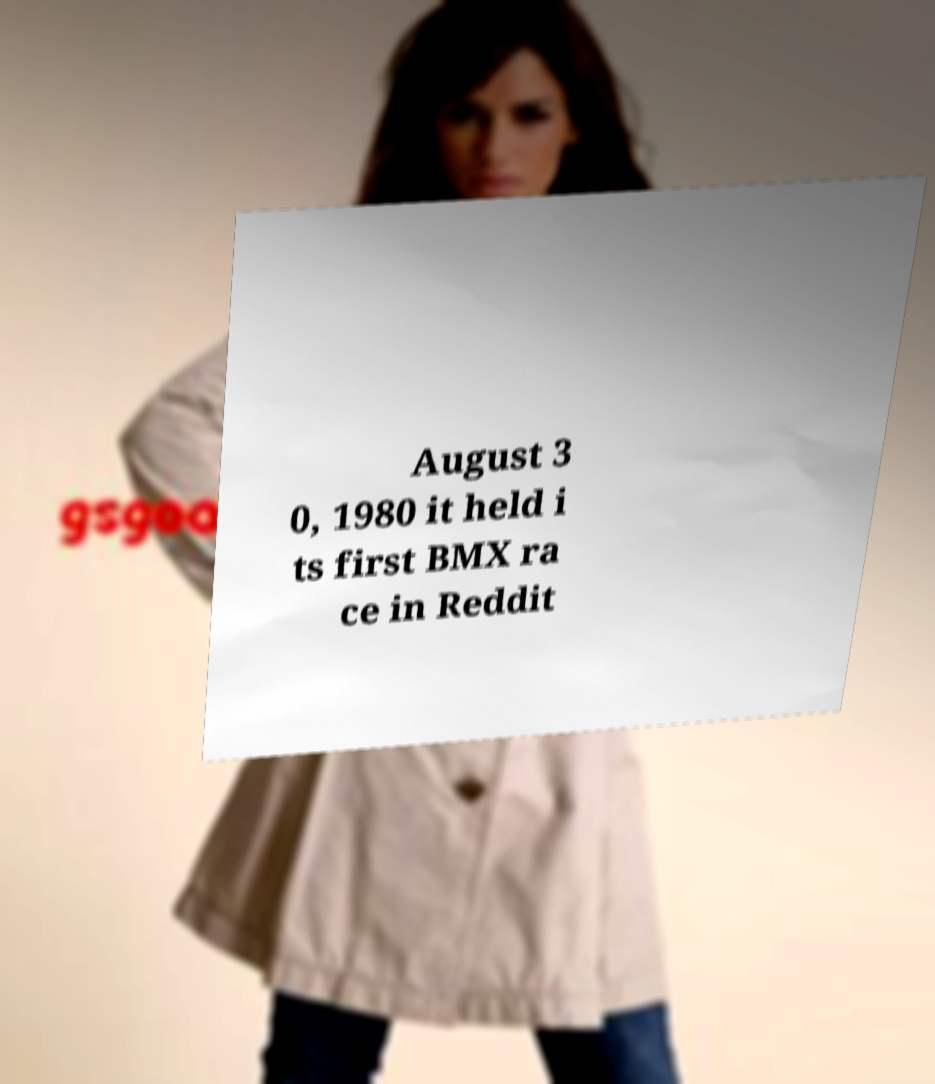Can you accurately transcribe the text from the provided image for me? August 3 0, 1980 it held i ts first BMX ra ce in Reddit 